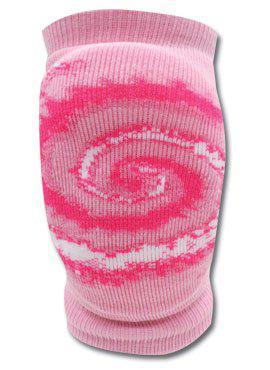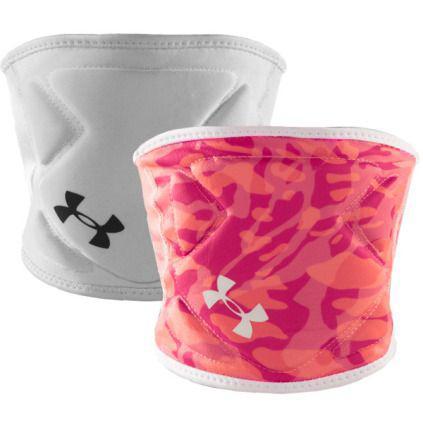The first image is the image on the left, the second image is the image on the right. For the images shown, is this caption "One image features a pair of legs wearing knee pads, and the other image includes a white knee pad." true? Answer yes or no. No. The first image is the image on the left, the second image is the image on the right. Assess this claim about the two images: "The knee guards are being worn by a person in at least one of the images.". Correct or not? Answer yes or no. No. 